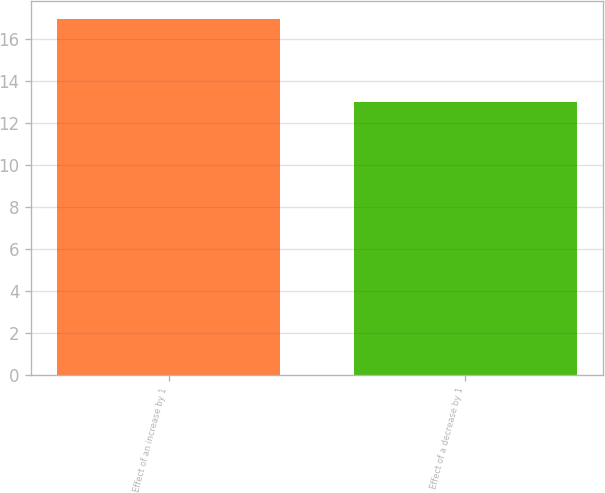<chart> <loc_0><loc_0><loc_500><loc_500><bar_chart><fcel>Effect of an increase by 1<fcel>Effect of a decrease by 1<nl><fcel>17<fcel>13<nl></chart> 